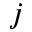<formula> <loc_0><loc_0><loc_500><loc_500>j</formula> 